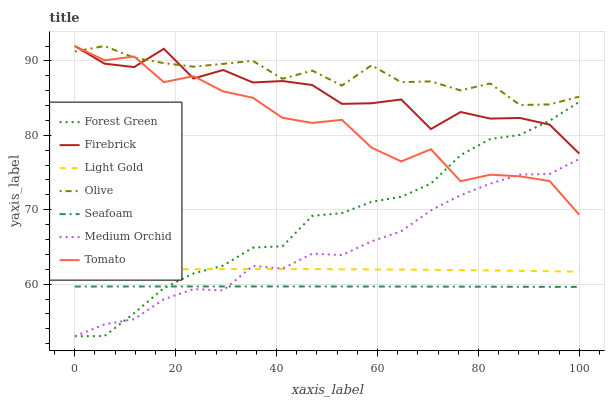Does Firebrick have the minimum area under the curve?
Answer yes or no. No. Does Firebrick have the maximum area under the curve?
Answer yes or no. No. Is Medium Orchid the smoothest?
Answer yes or no. No. Is Medium Orchid the roughest?
Answer yes or no. No. Does Firebrick have the lowest value?
Answer yes or no. No. Does Medium Orchid have the highest value?
Answer yes or no. No. Is Medium Orchid less than Olive?
Answer yes or no. Yes. Is Light Gold greater than Seafoam?
Answer yes or no. Yes. Does Medium Orchid intersect Olive?
Answer yes or no. No. 